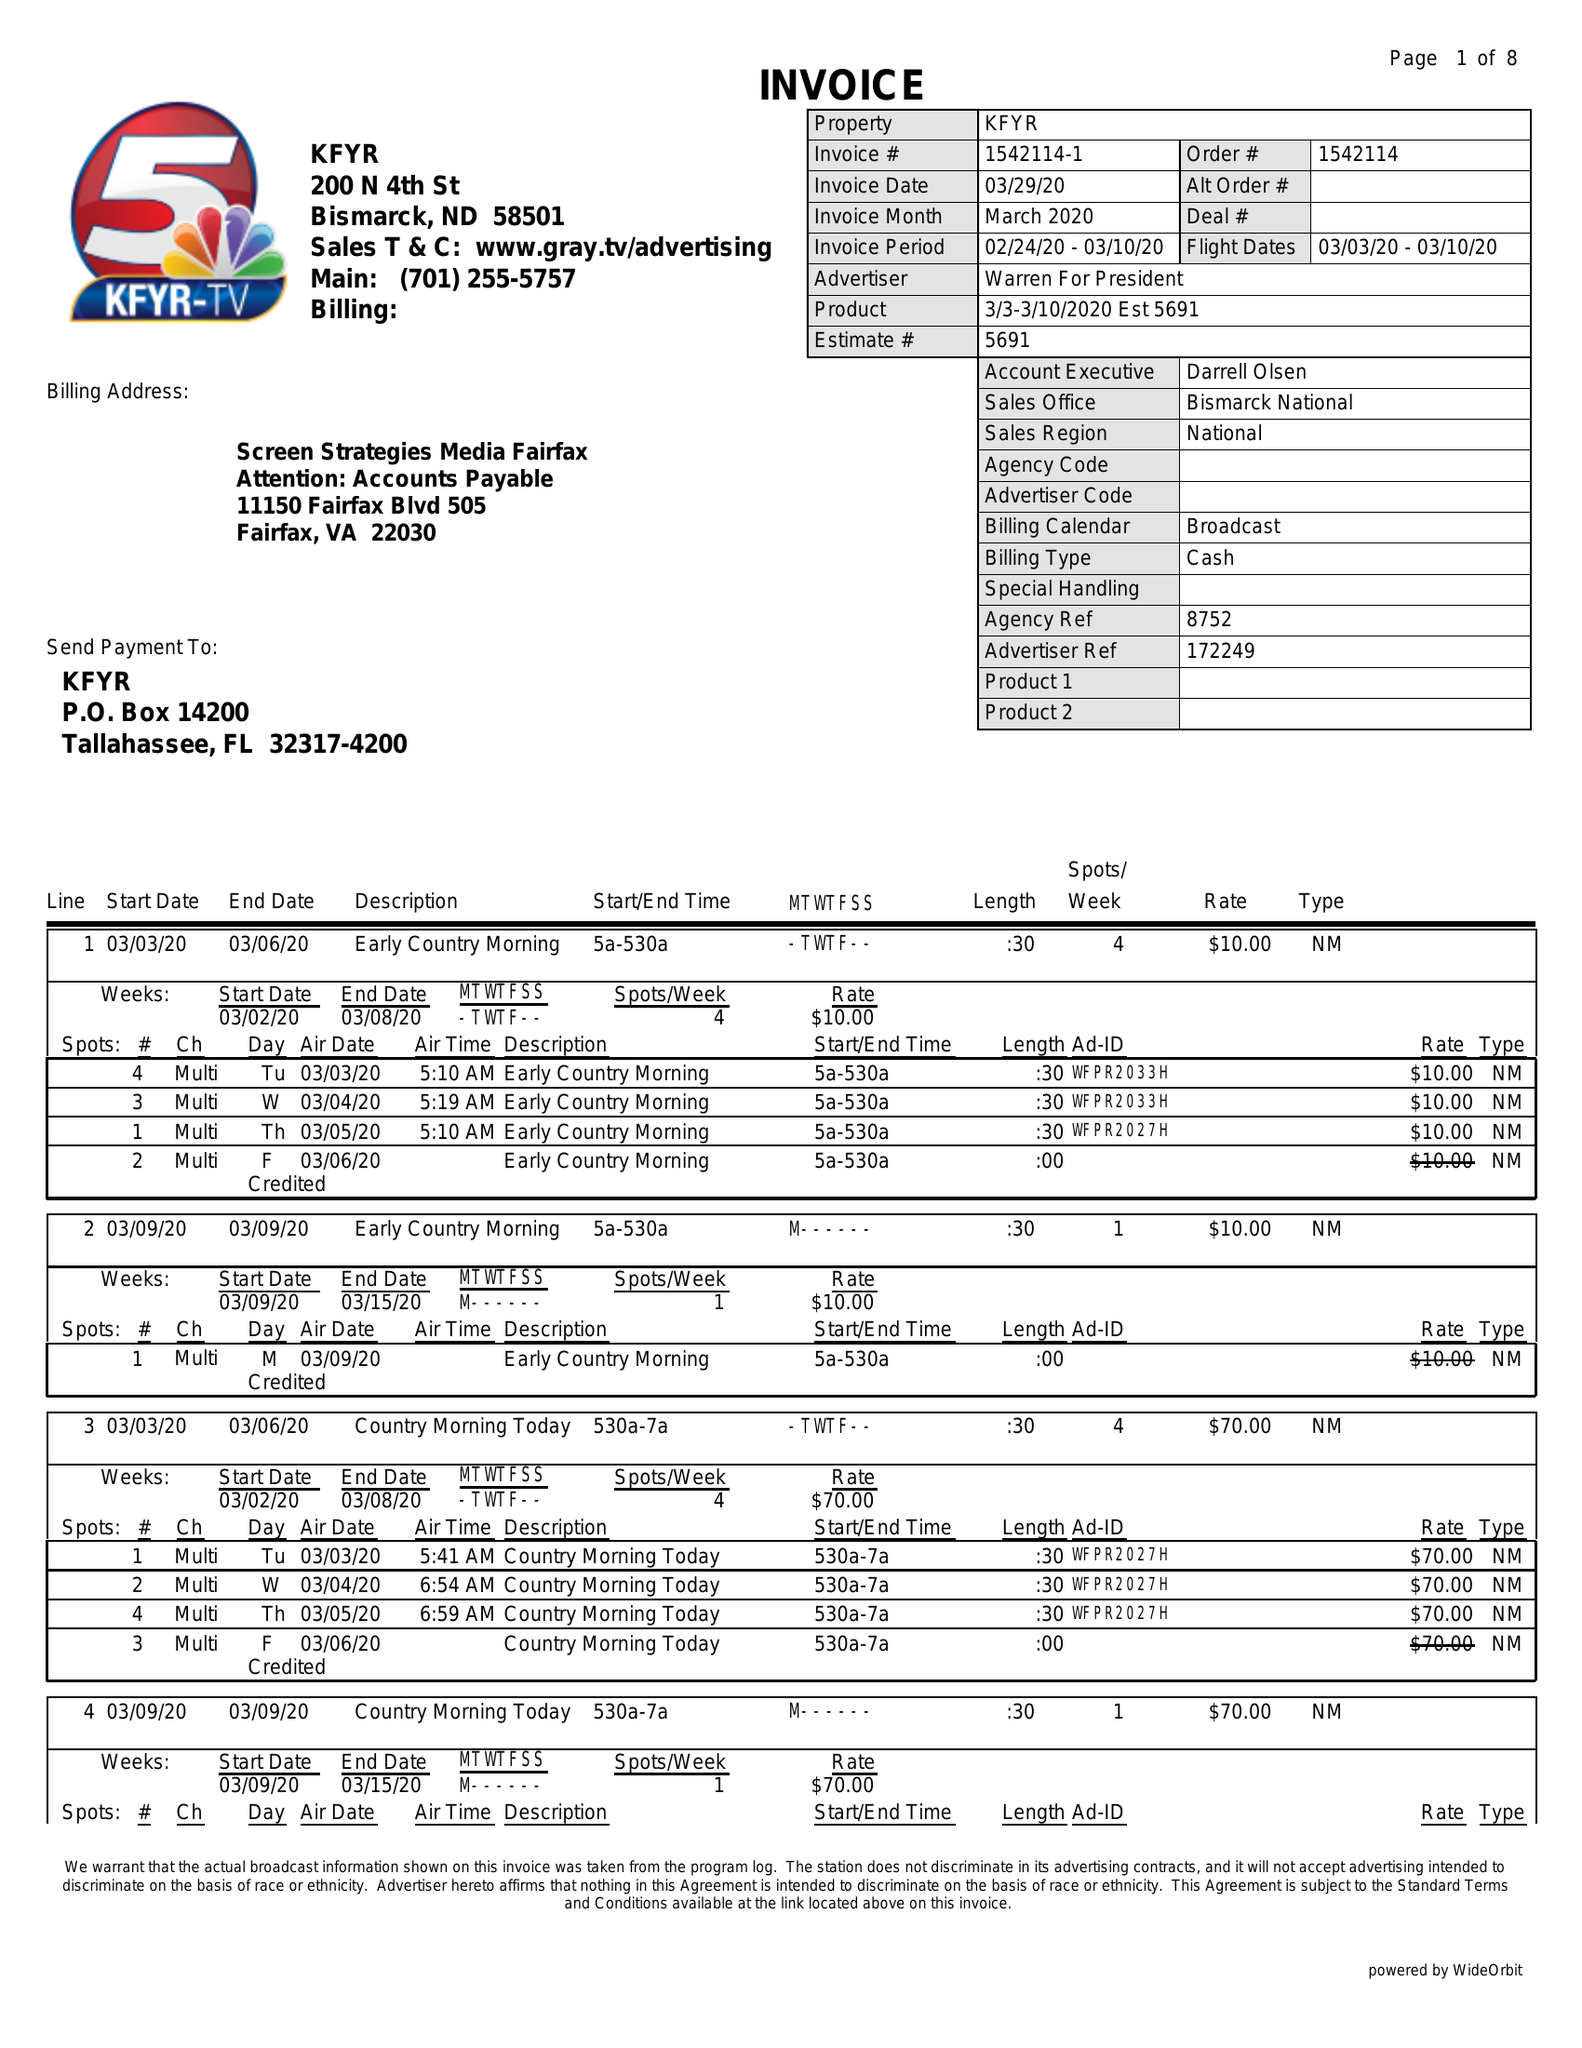What is the value for the gross_amount?
Answer the question using a single word or phrase. 7715.00 